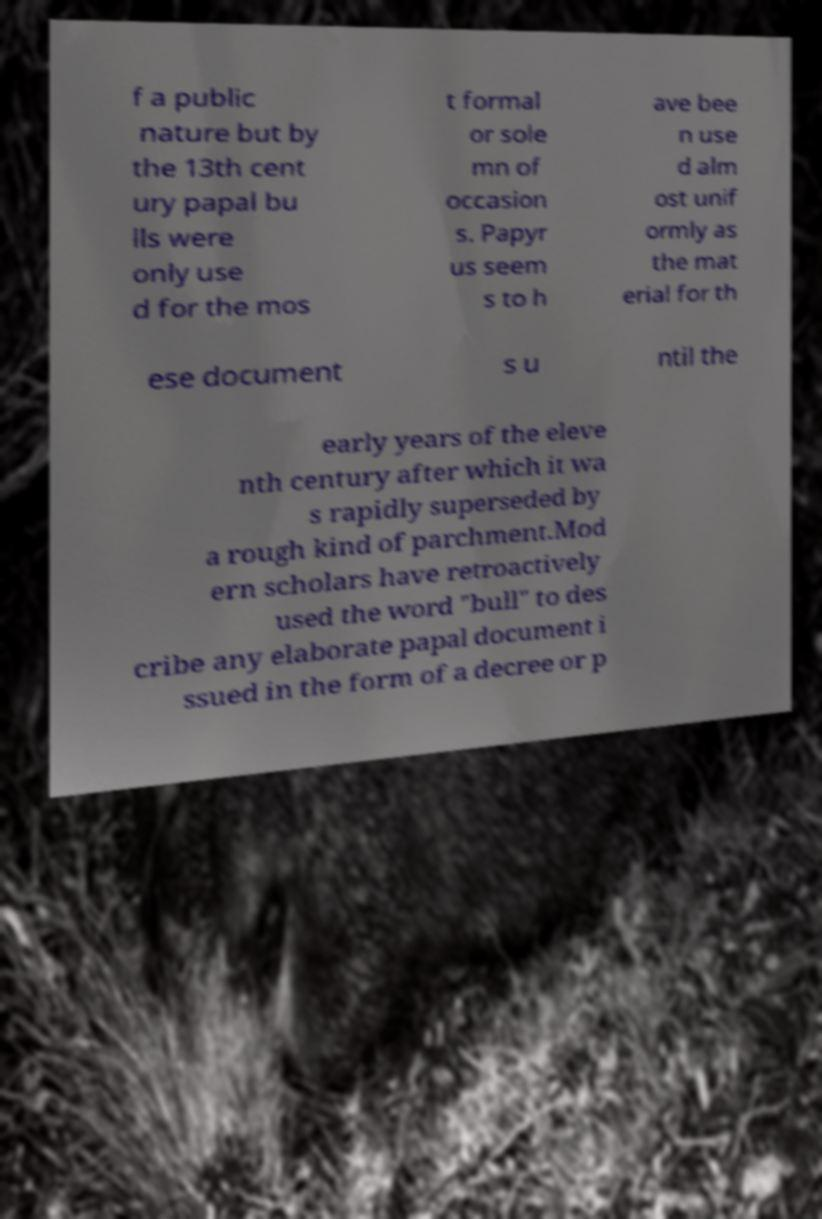What messages or text are displayed in this image? I need them in a readable, typed format. f a public nature but by the 13th cent ury papal bu lls were only use d for the mos t formal or sole mn of occasion s. Papyr us seem s to h ave bee n use d alm ost unif ormly as the mat erial for th ese document s u ntil the early years of the eleve nth century after which it wa s rapidly superseded by a rough kind of parchment.Mod ern scholars have retroactively used the word "bull" to des cribe any elaborate papal document i ssued in the form of a decree or p 